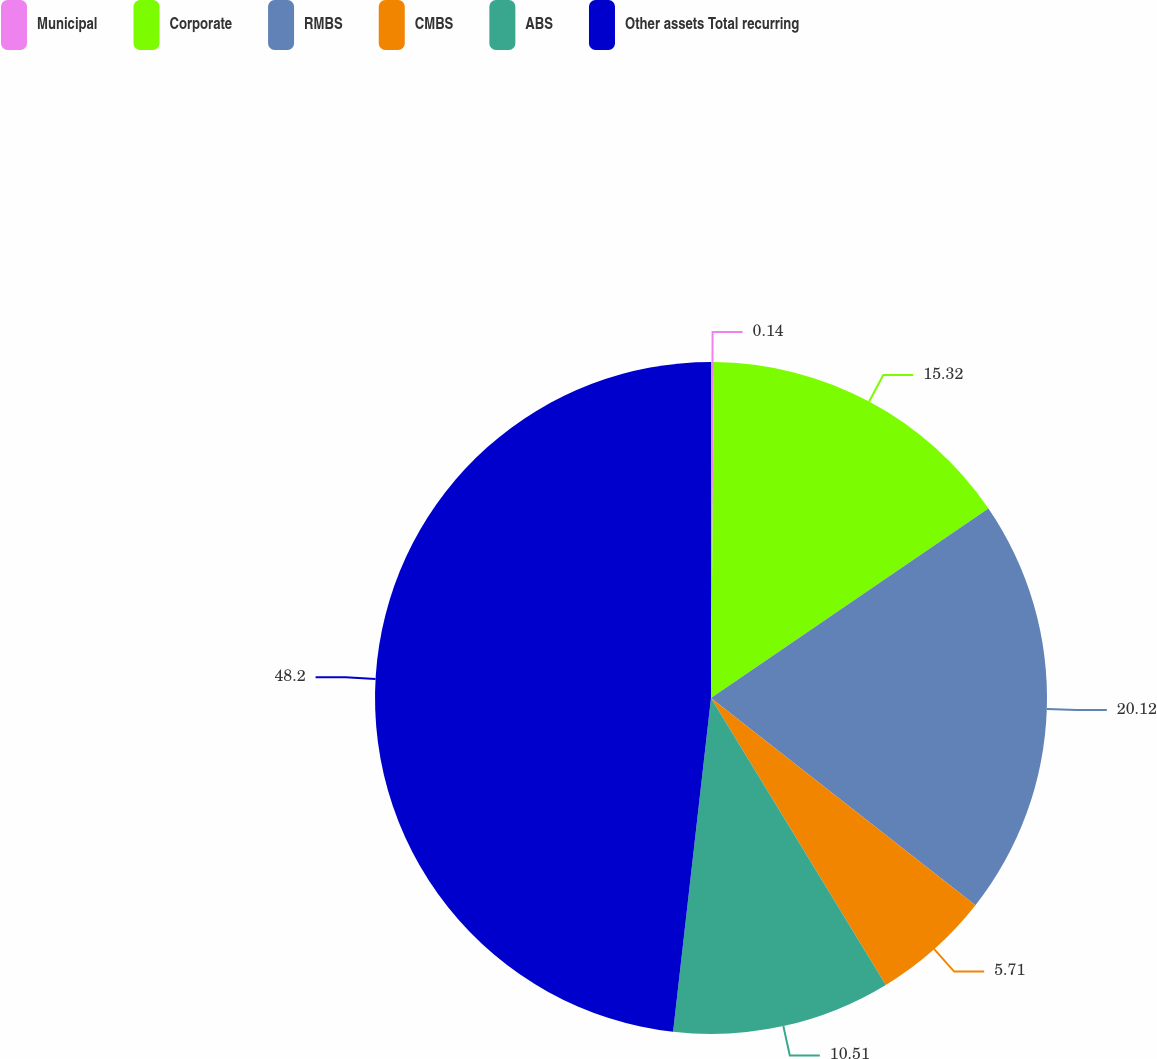Convert chart. <chart><loc_0><loc_0><loc_500><loc_500><pie_chart><fcel>Municipal<fcel>Corporate<fcel>RMBS<fcel>CMBS<fcel>ABS<fcel>Other assets Total recurring<nl><fcel>0.14%<fcel>15.32%<fcel>20.12%<fcel>5.71%<fcel>10.51%<fcel>48.2%<nl></chart> 